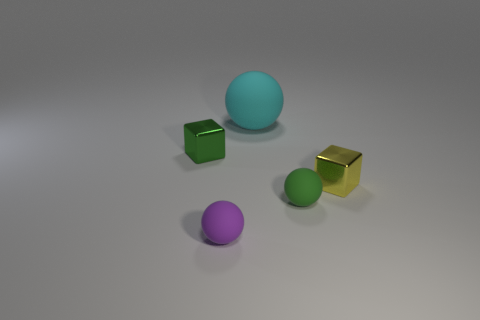How many small things have the same material as the big cyan ball?
Provide a short and direct response. 2. Does the large cyan object have the same material as the tiny thing in front of the green ball?
Provide a short and direct response. Yes. How many objects are small shiny cubes to the right of the green metallic block or small brown blocks?
Ensure brevity in your answer.  1. There is a rubber thing that is behind the tiny object that is left of the small matte object on the left side of the cyan object; what size is it?
Make the answer very short. Large. There is a metal cube on the left side of the small rubber object to the right of the tiny purple rubber sphere; what is its size?
Provide a short and direct response. Small. What number of small objects are either shiny cubes or blue metal objects?
Keep it short and to the point. 2. Are there fewer tiny purple things than red metal spheres?
Offer a very short reply. No. Is there anything else that is the same size as the cyan rubber object?
Keep it short and to the point. No. Is the number of large spheres greater than the number of large blue matte blocks?
Give a very brief answer. Yes. What number of other objects are the same color as the big object?
Make the answer very short. 0. 